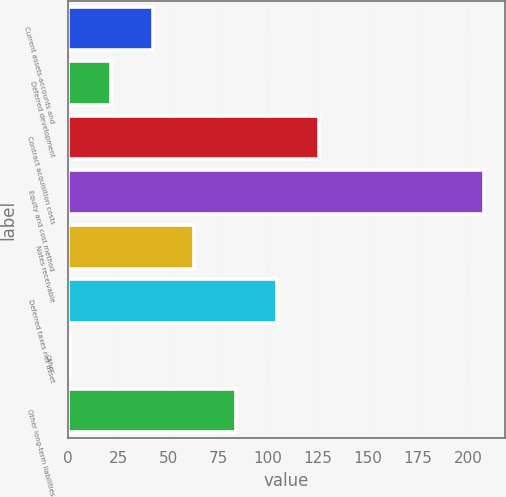Convert chart. <chart><loc_0><loc_0><loc_500><loc_500><bar_chart><fcel>Current assets-accounts and<fcel>Deferred development<fcel>Contract acquisition costs<fcel>Equity and cost method<fcel>Notes receivable<fcel>Deferred taxes net asset<fcel>Other<fcel>Other long-term liabilities<nl><fcel>42.4<fcel>21.7<fcel>125.2<fcel>208<fcel>63.1<fcel>104.5<fcel>1<fcel>83.8<nl></chart> 